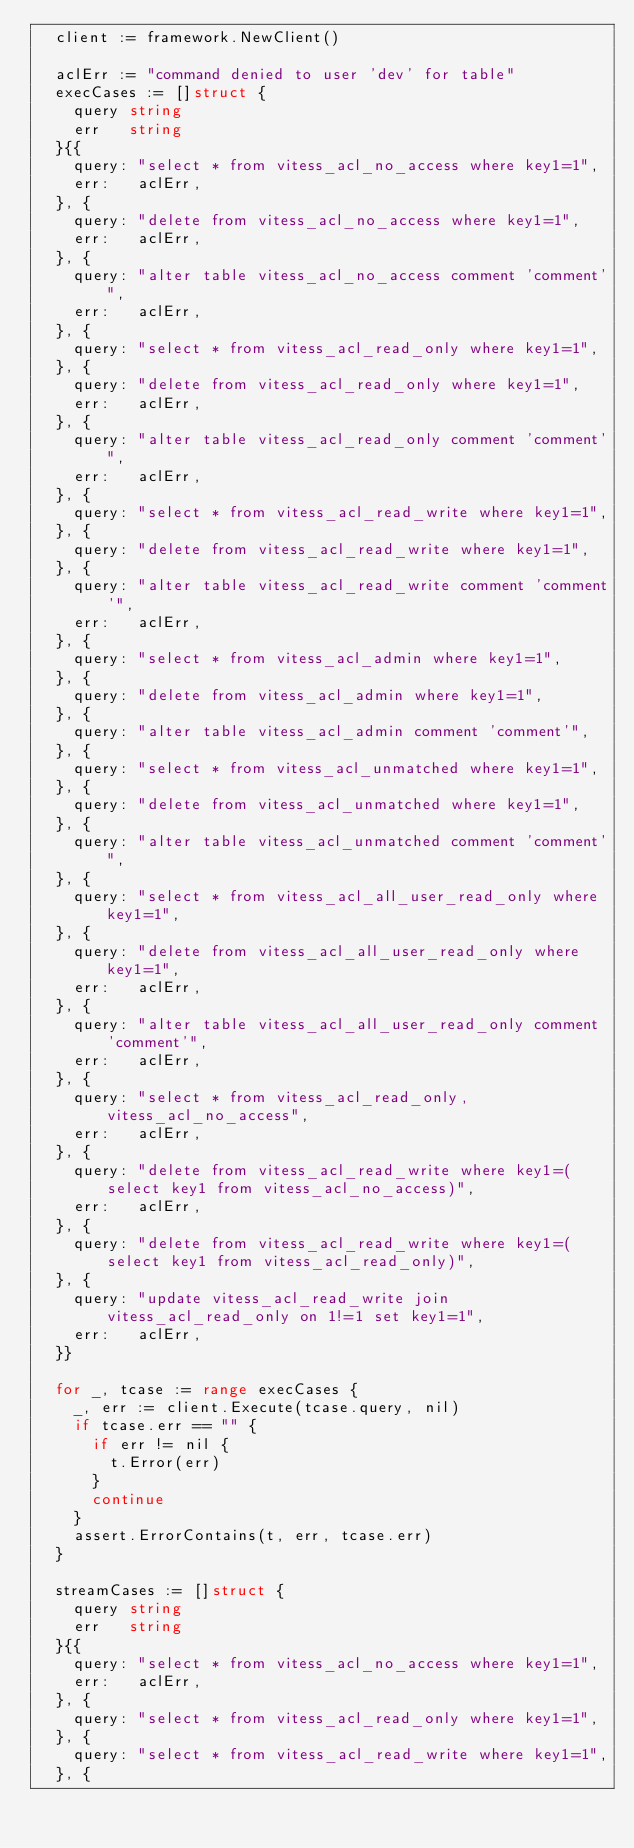<code> <loc_0><loc_0><loc_500><loc_500><_Go_>	client := framework.NewClient()

	aclErr := "command denied to user 'dev' for table"
	execCases := []struct {
		query string
		err   string
	}{{
		query: "select * from vitess_acl_no_access where key1=1",
		err:   aclErr,
	}, {
		query: "delete from vitess_acl_no_access where key1=1",
		err:   aclErr,
	}, {
		query: "alter table vitess_acl_no_access comment 'comment'",
		err:   aclErr,
	}, {
		query: "select * from vitess_acl_read_only where key1=1",
	}, {
		query: "delete from vitess_acl_read_only where key1=1",
		err:   aclErr,
	}, {
		query: "alter table vitess_acl_read_only comment 'comment'",
		err:   aclErr,
	}, {
		query: "select * from vitess_acl_read_write where key1=1",
	}, {
		query: "delete from vitess_acl_read_write where key1=1",
	}, {
		query: "alter table vitess_acl_read_write comment 'comment'",
		err:   aclErr,
	}, {
		query: "select * from vitess_acl_admin where key1=1",
	}, {
		query: "delete from vitess_acl_admin where key1=1",
	}, {
		query: "alter table vitess_acl_admin comment 'comment'",
	}, {
		query: "select * from vitess_acl_unmatched where key1=1",
	}, {
		query: "delete from vitess_acl_unmatched where key1=1",
	}, {
		query: "alter table vitess_acl_unmatched comment 'comment'",
	}, {
		query: "select * from vitess_acl_all_user_read_only where key1=1",
	}, {
		query: "delete from vitess_acl_all_user_read_only where key1=1",
		err:   aclErr,
	}, {
		query: "alter table vitess_acl_all_user_read_only comment 'comment'",
		err:   aclErr,
	}, {
		query: "select * from vitess_acl_read_only, vitess_acl_no_access",
		err:   aclErr,
	}, {
		query: "delete from vitess_acl_read_write where key1=(select key1 from vitess_acl_no_access)",
		err:   aclErr,
	}, {
		query: "delete from vitess_acl_read_write where key1=(select key1 from vitess_acl_read_only)",
	}, {
		query: "update vitess_acl_read_write join vitess_acl_read_only on 1!=1 set key1=1",
		err:   aclErr,
	}}

	for _, tcase := range execCases {
		_, err := client.Execute(tcase.query, nil)
		if tcase.err == "" {
			if err != nil {
				t.Error(err)
			}
			continue
		}
		assert.ErrorContains(t, err, tcase.err)
	}

	streamCases := []struct {
		query string
		err   string
	}{{
		query: "select * from vitess_acl_no_access where key1=1",
		err:   aclErr,
	}, {
		query: "select * from vitess_acl_read_only where key1=1",
	}, {
		query: "select * from vitess_acl_read_write where key1=1",
	}, {</code> 